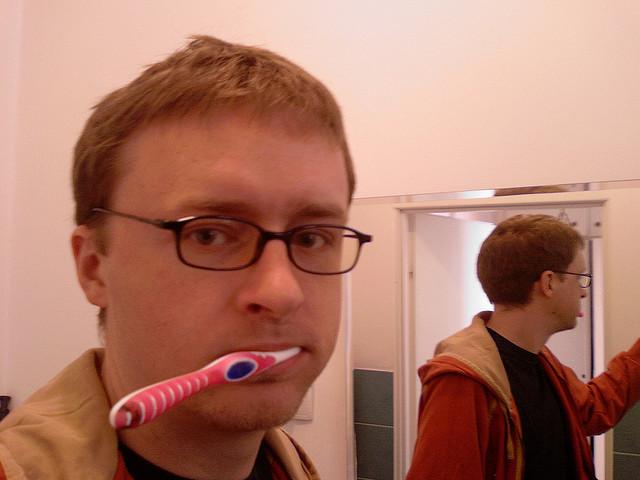What is the man eating?
Short answer required. Toothbrush. Where is the man standing?
Quick response, please. Bathroom. What hand is the boy using to brush his teeth?
Quick response, please. Right. What is the man in the middle of doing?
Concise answer only. Brushing teeth. What color is the man's hair?
Quick response, please. Red. What color is the man's toothbrush?
Quick response, please. Pink. What color is the man's jacket?
Be succinct. Red. 